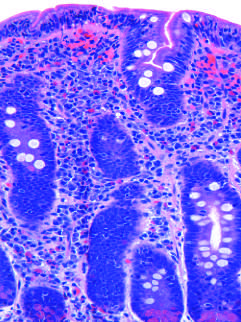nfiltration of the surface epithelium by t lymphocytes , which can be recognized by whose stained nuclei labeled t?
Answer the question using a single word or phrase. Their 